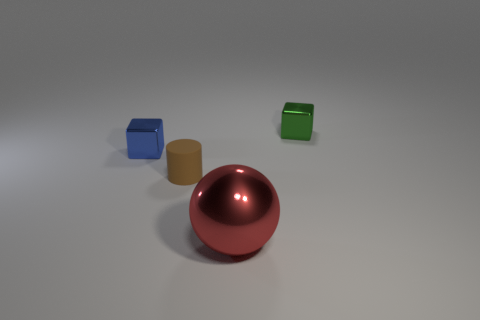Subtract all blue cubes. How many cubes are left? 1 Add 2 small shiny objects. How many objects exist? 6 Subtract 1 balls. How many balls are left? 0 Subtract all purple cubes. Subtract all cyan cylinders. How many cubes are left? 2 Subtract all big spheres. Subtract all metallic cylinders. How many objects are left? 3 Add 3 small green objects. How many small green objects are left? 4 Add 2 tiny cyan cylinders. How many tiny cyan cylinders exist? 2 Subtract 0 cyan spheres. How many objects are left? 4 Subtract all balls. How many objects are left? 3 